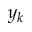Convert formula to latex. <formula><loc_0><loc_0><loc_500><loc_500>y _ { k }</formula> 